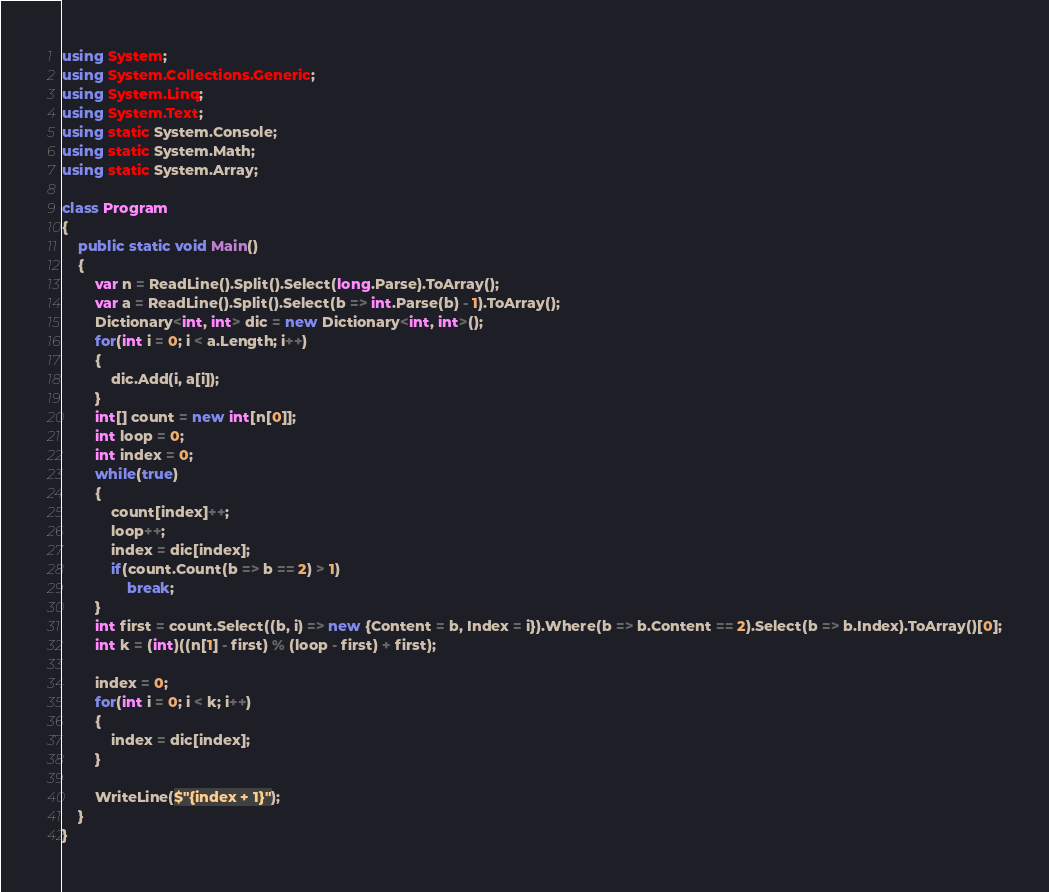<code> <loc_0><loc_0><loc_500><loc_500><_C#_>using System;
using System.Collections.Generic;
using System.Linq;
using System.Text;
using static System.Console;
using static System.Math;
using static System.Array;

class Program
{
    public static void Main()
    {
        var n = ReadLine().Split().Select(long.Parse).ToArray();
        var a = ReadLine().Split().Select(b => int.Parse(b) - 1).ToArray();
        Dictionary<int, int> dic = new Dictionary<int, int>();
        for(int i = 0; i < a.Length; i++)
        {
            dic.Add(i, a[i]);
        }
        int[] count = new int[n[0]];
        int loop = 0;
        int index = 0;
        while(true)
        {
            count[index]++;
            loop++;
            index = dic[index];
            if(count.Count(b => b == 2) > 1)
                break;
        }
        int first = count.Select((b, i) => new {Content = b, Index = i}).Where(b => b.Content == 2).Select(b => b.Index).ToArray()[0];
        int k = (int)((n[1] - first) % (loop - first) + first);

        index = 0;
        for(int i = 0; i < k; i++)
        {
            index = dic[index];
        }

        WriteLine($"{index + 1}");
    }
}
</code> 